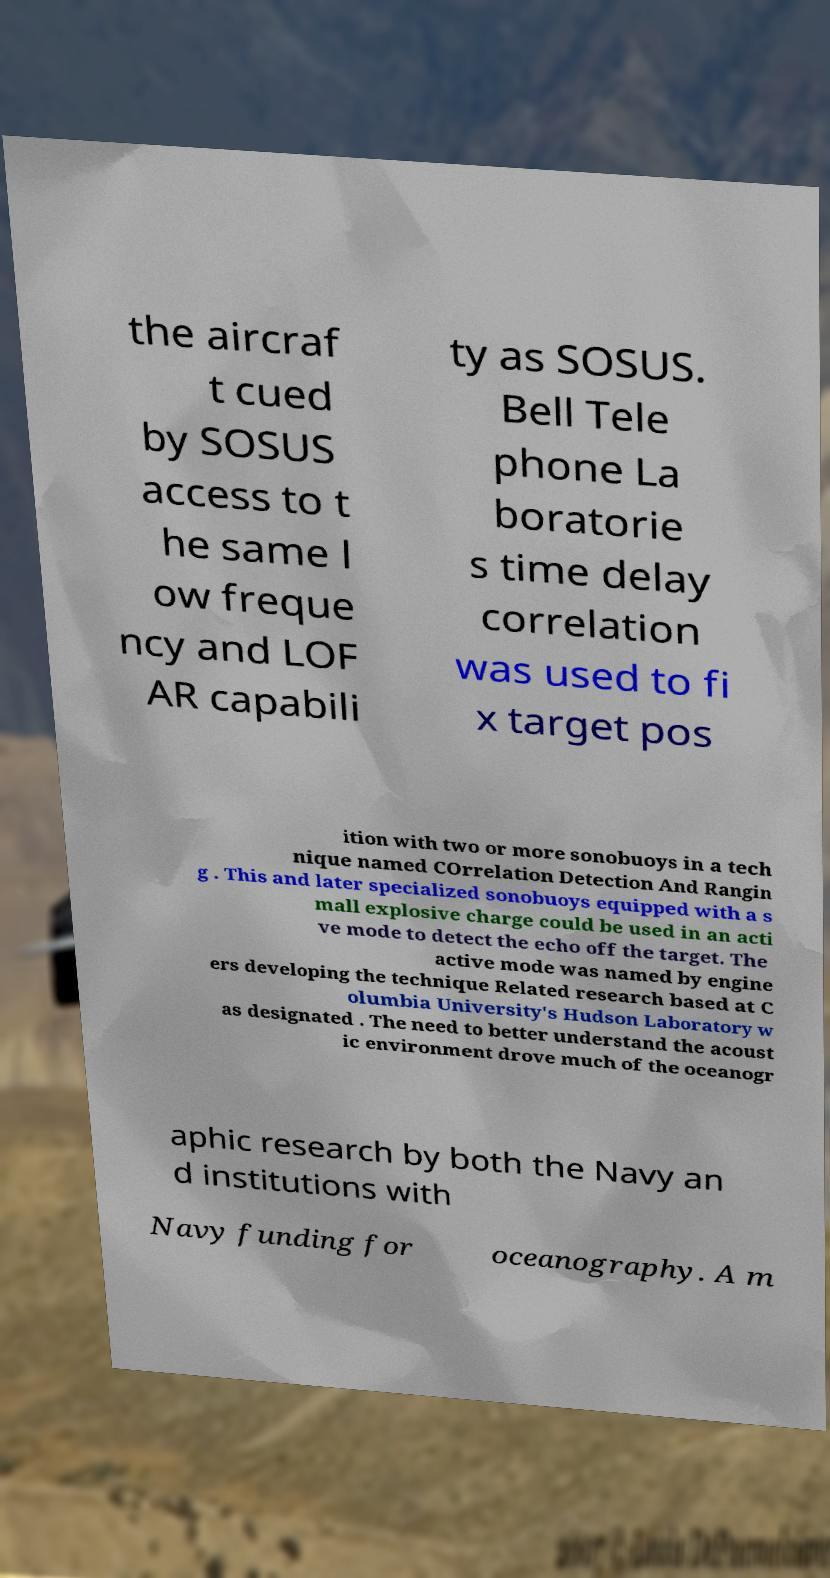Can you read and provide the text displayed in the image?This photo seems to have some interesting text. Can you extract and type it out for me? the aircraf t cued by SOSUS access to t he same l ow freque ncy and LOF AR capabili ty as SOSUS. Bell Tele phone La boratorie s time delay correlation was used to fi x target pos ition with two or more sonobuoys in a tech nique named COrrelation Detection And Rangin g . This and later specialized sonobuoys equipped with a s mall explosive charge could be used in an acti ve mode to detect the echo off the target. The active mode was named by engine ers developing the technique Related research based at C olumbia University's Hudson Laboratory w as designated . The need to better understand the acoust ic environment drove much of the oceanogr aphic research by both the Navy an d institutions with Navy funding for oceanography. A m 